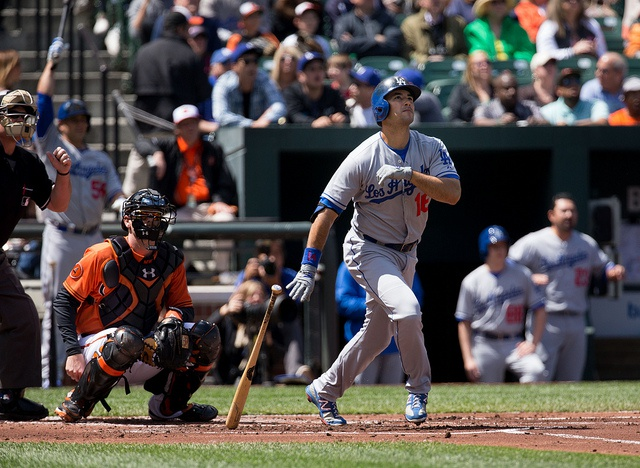Describe the objects in this image and their specific colors. I can see people in black, gray, darkgray, and teal tones, people in black, maroon, gray, and brown tones, people in black, gray, lightgray, and maroon tones, people in black, gray, maroon, and darkgray tones, and people in black, gray, lightgray, and darkgray tones in this image. 